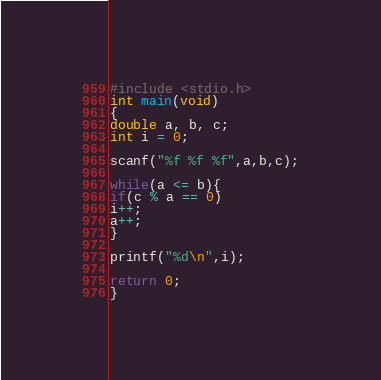Convert code to text. <code><loc_0><loc_0><loc_500><loc_500><_C_>#include <stdio.h>
int main(void)
{
double a, b, c;
int i = 0;

scanf("%f %f %f",a,b,c);

while(a <= b){
if(c % a == 0)
i++;
a++;
}

printf("%d\n",i);

return 0;
}</code> 